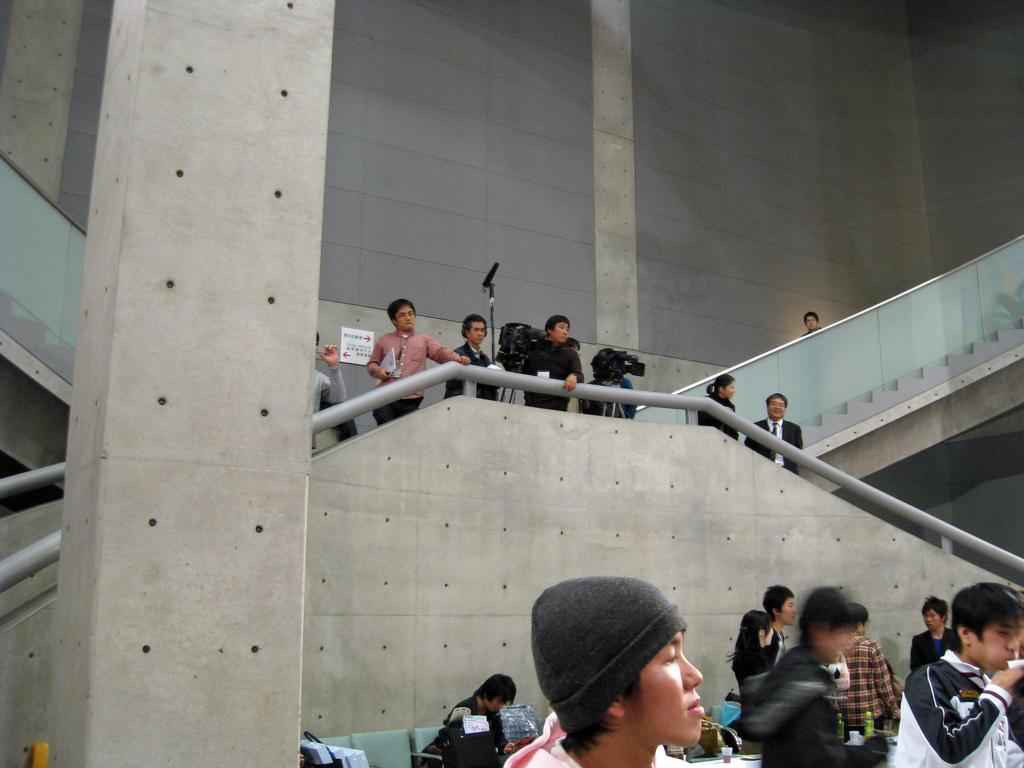How many people are in the image? There are people in the image, but the exact number is not specified. What is the person holding in the image? One person is holding an object in the image. What type of furniture is present in the image? There are chairs in the image. What type of container is visible in the image? There is a bottle in the image. What type of architectural feature is present in the image? There is a pillar in the image. What type of structure is present in the image? There are walls in the image. What type of pathway is present in the image? There are steps in the image. What type of safety feature is present in the image? There are railings in the image. What type of communication device is present in the image? There is a microphone (mike) in the image. What type of surface is present in the image for displaying information? There is a board in the image. How many trucks are parked near the tent during the rainstorm in the image? There is no mention of trucks, tents, or rainstorms in the image. The image only contains people, an object, chairs, a bottle, a pillar, walls, steps, railings, a microphone, and a board. 